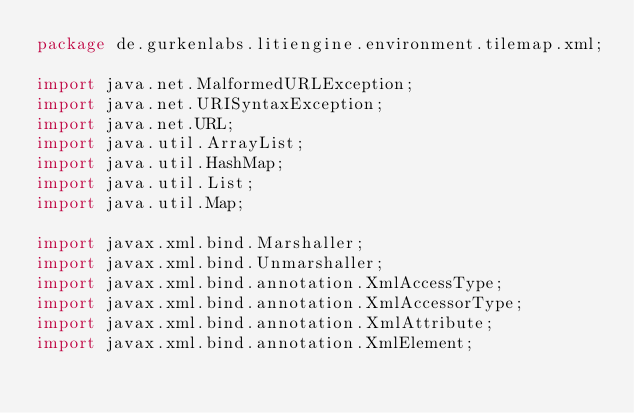<code> <loc_0><loc_0><loc_500><loc_500><_Java_>package de.gurkenlabs.litiengine.environment.tilemap.xml;

import java.net.MalformedURLException;
import java.net.URISyntaxException;
import java.net.URL;
import java.util.ArrayList;
import java.util.HashMap;
import java.util.List;
import java.util.Map;

import javax.xml.bind.Marshaller;
import javax.xml.bind.Unmarshaller;
import javax.xml.bind.annotation.XmlAccessType;
import javax.xml.bind.annotation.XmlAccessorType;
import javax.xml.bind.annotation.XmlAttribute;
import javax.xml.bind.annotation.XmlElement;</code> 